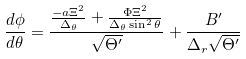<formula> <loc_0><loc_0><loc_500><loc_500>\frac { d \phi } { d \theta } = \frac { \frac { - a \Xi ^ { 2 } } { \Delta _ { \theta } } + \frac { \Phi \Xi ^ { 2 } } { \Delta _ { \theta } \sin ^ { 2 } \theta } } { \sqrt { \Theta ^ { \prime } } } + \frac { B ^ { \prime } } { \Delta _ { r } \sqrt { \Theta ^ { \prime } } }</formula> 